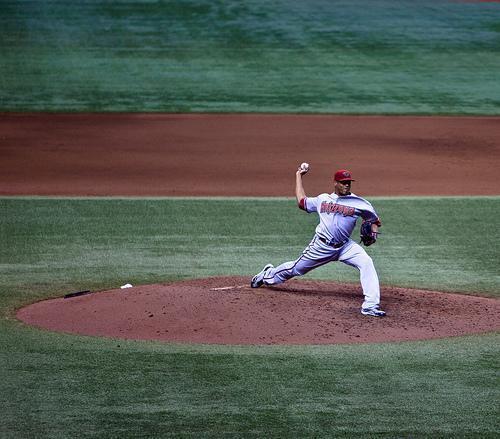How many players are there?
Give a very brief answer. 1. 